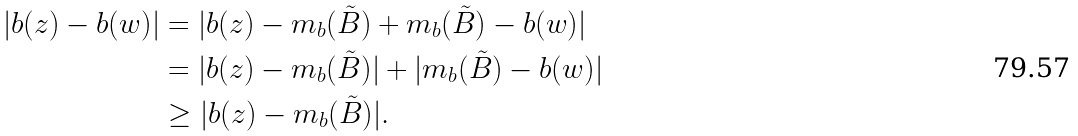<formula> <loc_0><loc_0><loc_500><loc_500>| b ( z ) - b ( w ) | & = | b ( z ) - m _ { b } ( \tilde { B } ) + m _ { b } ( \tilde { B } ) - b ( w ) | \\ & = | b ( z ) - m _ { b } ( \tilde { B } ) | + | m _ { b } ( \tilde { B } ) - b ( w ) | \\ & \geq | b ( z ) - m _ { b } ( \tilde { B } ) | .</formula> 